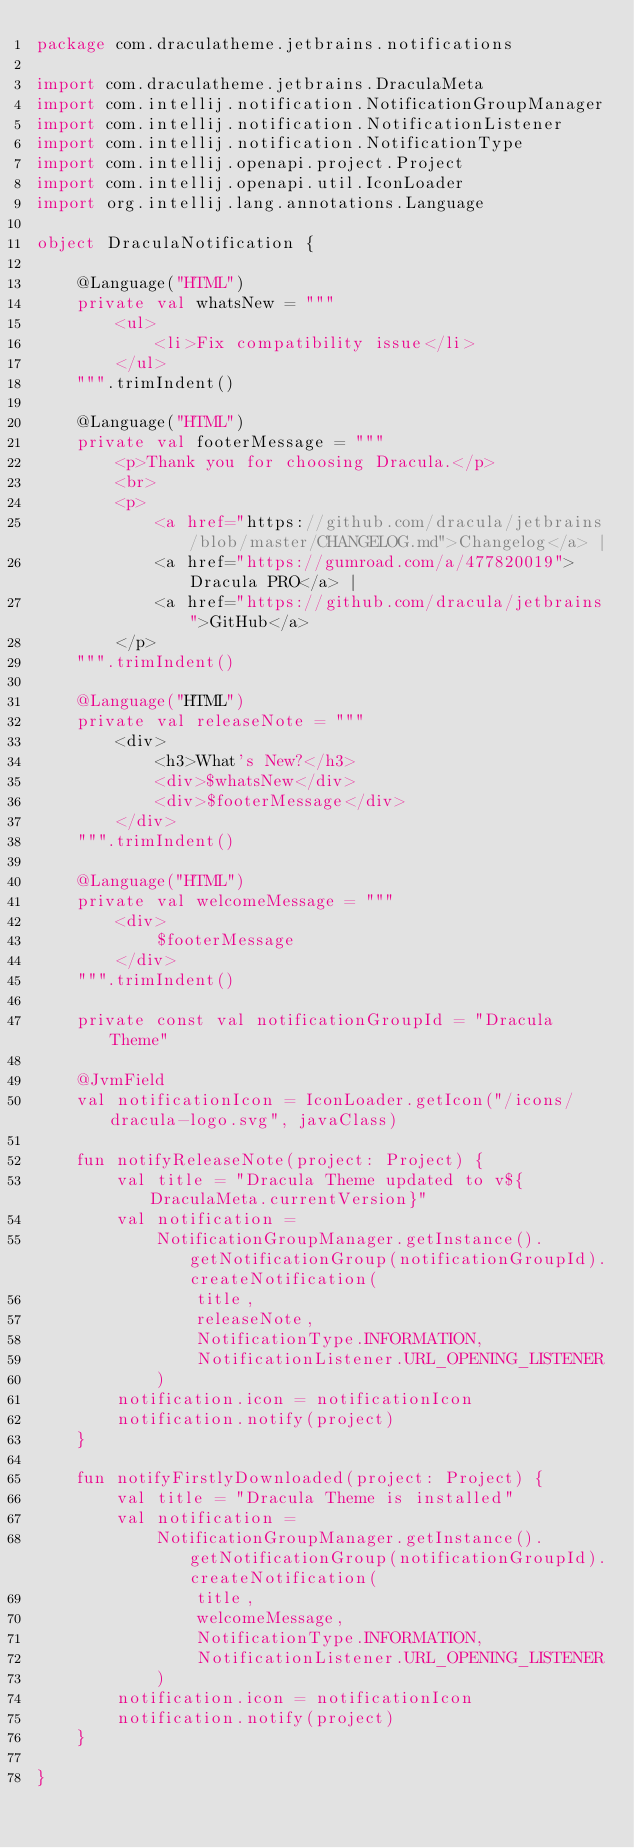Convert code to text. <code><loc_0><loc_0><loc_500><loc_500><_Kotlin_>package com.draculatheme.jetbrains.notifications

import com.draculatheme.jetbrains.DraculaMeta
import com.intellij.notification.NotificationGroupManager
import com.intellij.notification.NotificationListener
import com.intellij.notification.NotificationType
import com.intellij.openapi.project.Project
import com.intellij.openapi.util.IconLoader
import org.intellij.lang.annotations.Language

object DraculaNotification {

    @Language("HTML")
    private val whatsNew = """
        <ul>
            <li>Fix compatibility issue</li>
        </ul>
    """.trimIndent()

    @Language("HTML")
    private val footerMessage = """
        <p>Thank you for choosing Dracula.</p>
        <br>
        <p>
            <a href="https://github.com/dracula/jetbrains/blob/master/CHANGELOG.md">Changelog</a> | 
            <a href="https://gumroad.com/a/477820019">Dracula PRO</a> | 
            <a href="https://github.com/dracula/jetbrains">GitHub</a>
        </p>
    """.trimIndent()

    @Language("HTML")
    private val releaseNote = """
        <div>
            <h3>What's New?</h3>
            <div>$whatsNew</div>
            <div>$footerMessage</div>
        </div>
    """.trimIndent()

    @Language("HTML")
    private val welcomeMessage = """
        <div>
            $footerMessage
        </div>
    """.trimIndent()

    private const val notificationGroupId = "Dracula Theme"

    @JvmField
    val notificationIcon = IconLoader.getIcon("/icons/dracula-logo.svg", javaClass)

    fun notifyReleaseNote(project: Project) {
        val title = "Dracula Theme updated to v${DraculaMeta.currentVersion}"
        val notification =
            NotificationGroupManager.getInstance().getNotificationGroup(notificationGroupId).createNotification(
                title,
                releaseNote,
                NotificationType.INFORMATION,
                NotificationListener.URL_OPENING_LISTENER
            )
        notification.icon = notificationIcon
        notification.notify(project)
    }

    fun notifyFirstlyDownloaded(project: Project) {
        val title = "Dracula Theme is installed"
        val notification =
            NotificationGroupManager.getInstance().getNotificationGroup(notificationGroupId).createNotification(
                title,
                welcomeMessage,
                NotificationType.INFORMATION,
                NotificationListener.URL_OPENING_LISTENER
            )
        notification.icon = notificationIcon
        notification.notify(project)
    }

}
</code> 